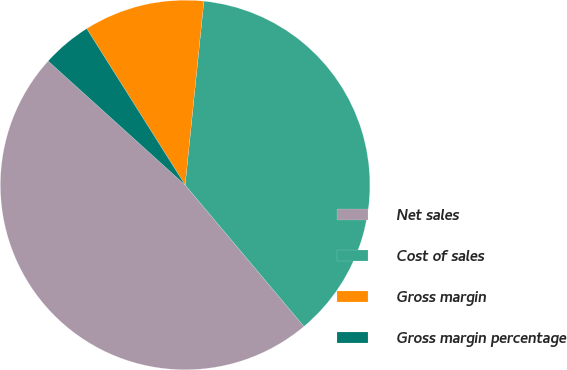Convert chart. <chart><loc_0><loc_0><loc_500><loc_500><pie_chart><fcel>Net sales<fcel>Cost of sales<fcel>Gross margin<fcel>Gross margin percentage<nl><fcel>47.82%<fcel>37.26%<fcel>10.56%<fcel>4.35%<nl></chart> 